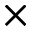<formula> <loc_0><loc_0><loc_500><loc_500>\times</formula> 